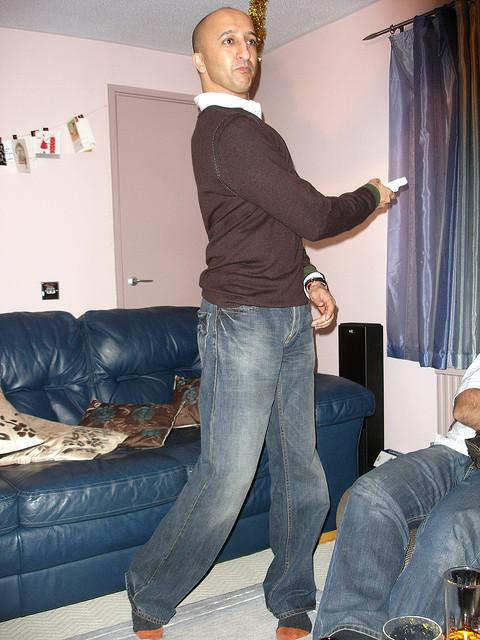What process is used to create the pillow fabric? sewing 